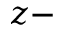<formula> <loc_0><loc_0><loc_500><loc_500>z -</formula> 